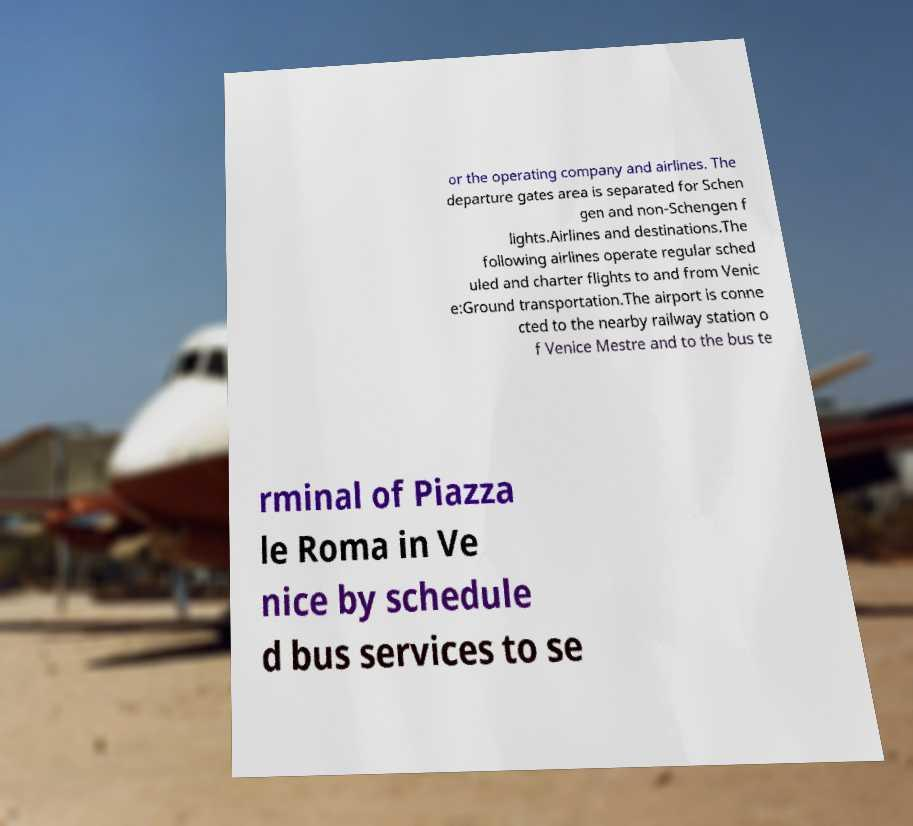Please read and relay the text visible in this image. What does it say? or the operating company and airlines. The departure gates area is separated for Schen gen and non-Schengen f lights.Airlines and destinations.The following airlines operate regular sched uled and charter flights to and from Venic e:Ground transportation.The airport is conne cted to the nearby railway station o f Venice Mestre and to the bus te rminal of Piazza le Roma in Ve nice by schedule d bus services to se 